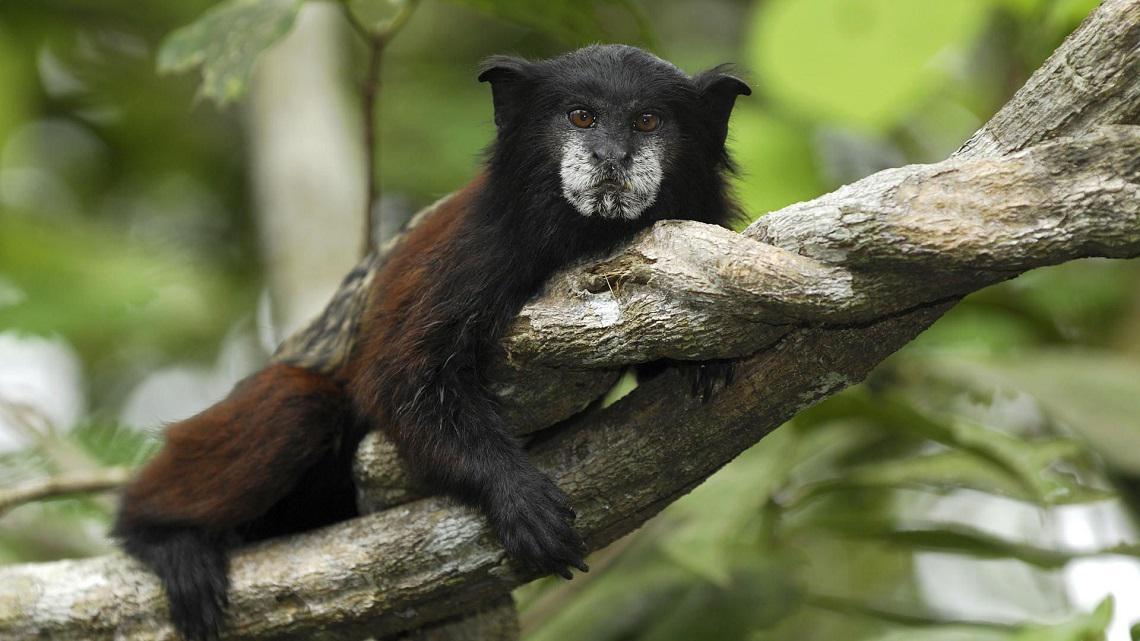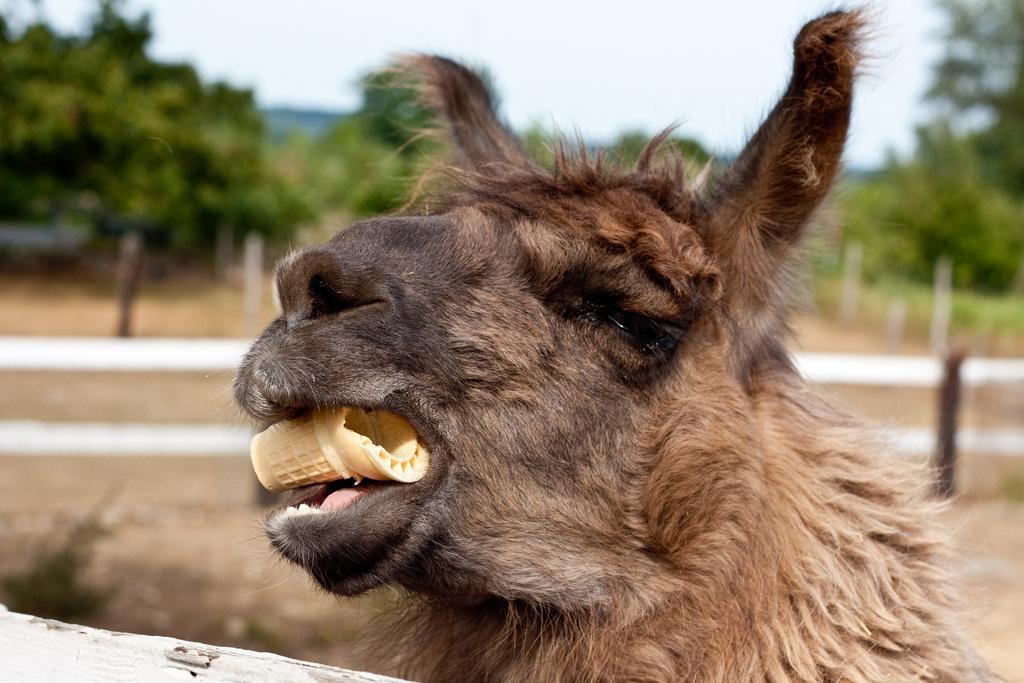The first image is the image on the left, the second image is the image on the right. Analyze the images presented: Is the assertion "An image contains a llama clenching something in its mouth." valid? Answer yes or no. Yes. The first image is the image on the left, the second image is the image on the right. Analyze the images presented: Is the assertion "At least one llama is eating food." valid? Answer yes or no. Yes. 